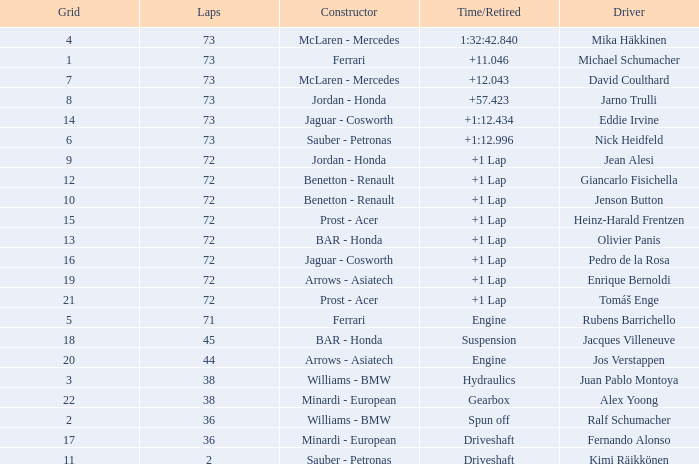Who is the constructor when the laps is more than 72 and the driver is eddie irvine? Jaguar - Cosworth. 